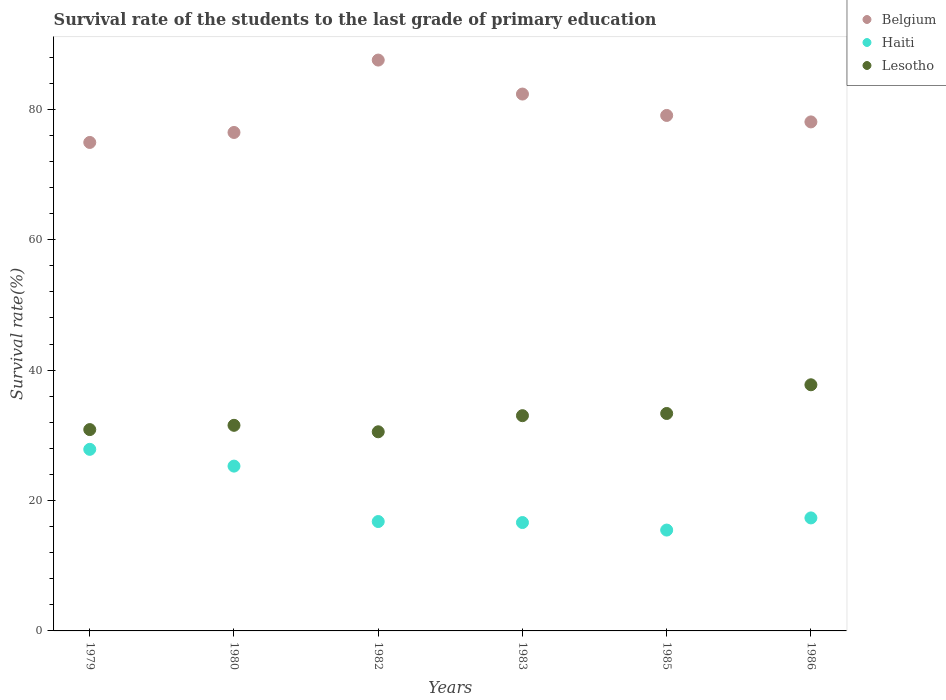Is the number of dotlines equal to the number of legend labels?
Ensure brevity in your answer.  Yes. What is the survival rate of the students in Lesotho in 1983?
Your answer should be very brief. 33.01. Across all years, what is the maximum survival rate of the students in Lesotho?
Make the answer very short. 37.75. Across all years, what is the minimum survival rate of the students in Haiti?
Your response must be concise. 15.47. In which year was the survival rate of the students in Haiti maximum?
Provide a short and direct response. 1979. What is the total survival rate of the students in Haiti in the graph?
Your answer should be compact. 119.33. What is the difference between the survival rate of the students in Lesotho in 1983 and that in 1985?
Provide a short and direct response. -0.34. What is the difference between the survival rate of the students in Haiti in 1985 and the survival rate of the students in Lesotho in 1980?
Provide a succinct answer. -16.07. What is the average survival rate of the students in Haiti per year?
Give a very brief answer. 19.89. In the year 1982, what is the difference between the survival rate of the students in Haiti and survival rate of the students in Lesotho?
Ensure brevity in your answer.  -13.77. In how many years, is the survival rate of the students in Haiti greater than 44 %?
Provide a succinct answer. 0. What is the ratio of the survival rate of the students in Haiti in 1979 to that in 1980?
Give a very brief answer. 1.1. Is the difference between the survival rate of the students in Haiti in 1980 and 1983 greater than the difference between the survival rate of the students in Lesotho in 1980 and 1983?
Ensure brevity in your answer.  Yes. What is the difference between the highest and the second highest survival rate of the students in Lesotho?
Your answer should be very brief. 4.4. What is the difference between the highest and the lowest survival rate of the students in Belgium?
Provide a short and direct response. 12.63. In how many years, is the survival rate of the students in Lesotho greater than the average survival rate of the students in Lesotho taken over all years?
Make the answer very short. 3. How many dotlines are there?
Make the answer very short. 3. How many years are there in the graph?
Offer a very short reply. 6. What is the difference between two consecutive major ticks on the Y-axis?
Your answer should be very brief. 20. Are the values on the major ticks of Y-axis written in scientific E-notation?
Give a very brief answer. No. Does the graph contain any zero values?
Give a very brief answer. No. Where does the legend appear in the graph?
Your answer should be very brief. Top right. How are the legend labels stacked?
Make the answer very short. Vertical. What is the title of the graph?
Keep it short and to the point. Survival rate of the students to the last grade of primary education. What is the label or title of the X-axis?
Offer a terse response. Years. What is the label or title of the Y-axis?
Your answer should be very brief. Survival rate(%). What is the Survival rate(%) of Belgium in 1979?
Your answer should be compact. 74.92. What is the Survival rate(%) of Haiti in 1979?
Provide a short and direct response. 27.85. What is the Survival rate(%) of Lesotho in 1979?
Your response must be concise. 30.88. What is the Survival rate(%) in Belgium in 1980?
Give a very brief answer. 76.45. What is the Survival rate(%) in Haiti in 1980?
Provide a short and direct response. 25.28. What is the Survival rate(%) of Lesotho in 1980?
Offer a terse response. 31.53. What is the Survival rate(%) of Belgium in 1982?
Offer a terse response. 87.55. What is the Survival rate(%) in Haiti in 1982?
Your response must be concise. 16.78. What is the Survival rate(%) in Lesotho in 1982?
Provide a succinct answer. 30.54. What is the Survival rate(%) in Belgium in 1983?
Offer a very short reply. 82.34. What is the Survival rate(%) of Haiti in 1983?
Keep it short and to the point. 16.62. What is the Survival rate(%) in Lesotho in 1983?
Give a very brief answer. 33.01. What is the Survival rate(%) of Belgium in 1985?
Your response must be concise. 79.06. What is the Survival rate(%) in Haiti in 1985?
Your answer should be compact. 15.47. What is the Survival rate(%) of Lesotho in 1985?
Offer a very short reply. 33.35. What is the Survival rate(%) of Belgium in 1986?
Offer a very short reply. 78.07. What is the Survival rate(%) of Haiti in 1986?
Provide a short and direct response. 17.33. What is the Survival rate(%) of Lesotho in 1986?
Your response must be concise. 37.75. Across all years, what is the maximum Survival rate(%) in Belgium?
Your answer should be compact. 87.55. Across all years, what is the maximum Survival rate(%) in Haiti?
Your answer should be very brief. 27.85. Across all years, what is the maximum Survival rate(%) of Lesotho?
Provide a short and direct response. 37.75. Across all years, what is the minimum Survival rate(%) of Belgium?
Give a very brief answer. 74.92. Across all years, what is the minimum Survival rate(%) of Haiti?
Give a very brief answer. 15.47. Across all years, what is the minimum Survival rate(%) of Lesotho?
Your answer should be very brief. 30.54. What is the total Survival rate(%) in Belgium in the graph?
Your response must be concise. 478.4. What is the total Survival rate(%) of Haiti in the graph?
Give a very brief answer. 119.33. What is the total Survival rate(%) in Lesotho in the graph?
Make the answer very short. 197.07. What is the difference between the Survival rate(%) in Belgium in 1979 and that in 1980?
Your response must be concise. -1.53. What is the difference between the Survival rate(%) in Haiti in 1979 and that in 1980?
Offer a terse response. 2.57. What is the difference between the Survival rate(%) of Lesotho in 1979 and that in 1980?
Offer a very short reply. -0.65. What is the difference between the Survival rate(%) in Belgium in 1979 and that in 1982?
Provide a short and direct response. -12.63. What is the difference between the Survival rate(%) in Haiti in 1979 and that in 1982?
Your answer should be compact. 11.07. What is the difference between the Survival rate(%) of Lesotho in 1979 and that in 1982?
Provide a short and direct response. 0.34. What is the difference between the Survival rate(%) of Belgium in 1979 and that in 1983?
Your answer should be very brief. -7.42. What is the difference between the Survival rate(%) of Haiti in 1979 and that in 1983?
Provide a short and direct response. 11.23. What is the difference between the Survival rate(%) of Lesotho in 1979 and that in 1983?
Your response must be concise. -2.13. What is the difference between the Survival rate(%) of Belgium in 1979 and that in 1985?
Ensure brevity in your answer.  -4.14. What is the difference between the Survival rate(%) in Haiti in 1979 and that in 1985?
Give a very brief answer. 12.38. What is the difference between the Survival rate(%) in Lesotho in 1979 and that in 1985?
Your answer should be compact. -2.47. What is the difference between the Survival rate(%) in Belgium in 1979 and that in 1986?
Your answer should be very brief. -3.15. What is the difference between the Survival rate(%) in Haiti in 1979 and that in 1986?
Give a very brief answer. 10.52. What is the difference between the Survival rate(%) in Lesotho in 1979 and that in 1986?
Provide a succinct answer. -6.87. What is the difference between the Survival rate(%) of Belgium in 1980 and that in 1982?
Your answer should be compact. -11.1. What is the difference between the Survival rate(%) in Haiti in 1980 and that in 1982?
Make the answer very short. 8.5. What is the difference between the Survival rate(%) of Belgium in 1980 and that in 1983?
Ensure brevity in your answer.  -5.89. What is the difference between the Survival rate(%) in Haiti in 1980 and that in 1983?
Provide a short and direct response. 8.65. What is the difference between the Survival rate(%) of Lesotho in 1980 and that in 1983?
Your answer should be compact. -1.48. What is the difference between the Survival rate(%) in Belgium in 1980 and that in 1985?
Provide a short and direct response. -2.61. What is the difference between the Survival rate(%) of Haiti in 1980 and that in 1985?
Your answer should be very brief. 9.81. What is the difference between the Survival rate(%) of Lesotho in 1980 and that in 1985?
Give a very brief answer. -1.82. What is the difference between the Survival rate(%) in Belgium in 1980 and that in 1986?
Keep it short and to the point. -1.62. What is the difference between the Survival rate(%) of Haiti in 1980 and that in 1986?
Your answer should be very brief. 7.95. What is the difference between the Survival rate(%) in Lesotho in 1980 and that in 1986?
Your response must be concise. -6.22. What is the difference between the Survival rate(%) in Belgium in 1982 and that in 1983?
Your answer should be compact. 5.21. What is the difference between the Survival rate(%) of Haiti in 1982 and that in 1983?
Give a very brief answer. 0.15. What is the difference between the Survival rate(%) in Lesotho in 1982 and that in 1983?
Offer a terse response. -2.47. What is the difference between the Survival rate(%) of Belgium in 1982 and that in 1985?
Your response must be concise. 8.49. What is the difference between the Survival rate(%) of Haiti in 1982 and that in 1985?
Ensure brevity in your answer.  1.31. What is the difference between the Survival rate(%) in Lesotho in 1982 and that in 1985?
Your answer should be compact. -2.81. What is the difference between the Survival rate(%) of Belgium in 1982 and that in 1986?
Give a very brief answer. 9.48. What is the difference between the Survival rate(%) of Haiti in 1982 and that in 1986?
Your answer should be very brief. -0.56. What is the difference between the Survival rate(%) of Lesotho in 1982 and that in 1986?
Offer a terse response. -7.21. What is the difference between the Survival rate(%) of Belgium in 1983 and that in 1985?
Offer a terse response. 3.28. What is the difference between the Survival rate(%) in Haiti in 1983 and that in 1985?
Provide a succinct answer. 1.16. What is the difference between the Survival rate(%) of Lesotho in 1983 and that in 1985?
Your answer should be compact. -0.34. What is the difference between the Survival rate(%) in Belgium in 1983 and that in 1986?
Keep it short and to the point. 4.27. What is the difference between the Survival rate(%) of Haiti in 1983 and that in 1986?
Your answer should be compact. -0.71. What is the difference between the Survival rate(%) of Lesotho in 1983 and that in 1986?
Your response must be concise. -4.74. What is the difference between the Survival rate(%) in Belgium in 1985 and that in 1986?
Give a very brief answer. 0.99. What is the difference between the Survival rate(%) in Haiti in 1985 and that in 1986?
Offer a very short reply. -1.86. What is the difference between the Survival rate(%) of Lesotho in 1985 and that in 1986?
Give a very brief answer. -4.4. What is the difference between the Survival rate(%) in Belgium in 1979 and the Survival rate(%) in Haiti in 1980?
Your answer should be very brief. 49.64. What is the difference between the Survival rate(%) of Belgium in 1979 and the Survival rate(%) of Lesotho in 1980?
Your answer should be compact. 43.39. What is the difference between the Survival rate(%) of Haiti in 1979 and the Survival rate(%) of Lesotho in 1980?
Give a very brief answer. -3.68. What is the difference between the Survival rate(%) of Belgium in 1979 and the Survival rate(%) of Haiti in 1982?
Your answer should be very brief. 58.14. What is the difference between the Survival rate(%) in Belgium in 1979 and the Survival rate(%) in Lesotho in 1982?
Your response must be concise. 44.38. What is the difference between the Survival rate(%) in Haiti in 1979 and the Survival rate(%) in Lesotho in 1982?
Make the answer very short. -2.69. What is the difference between the Survival rate(%) of Belgium in 1979 and the Survival rate(%) of Haiti in 1983?
Your response must be concise. 58.3. What is the difference between the Survival rate(%) in Belgium in 1979 and the Survival rate(%) in Lesotho in 1983?
Offer a terse response. 41.91. What is the difference between the Survival rate(%) of Haiti in 1979 and the Survival rate(%) of Lesotho in 1983?
Make the answer very short. -5.16. What is the difference between the Survival rate(%) in Belgium in 1979 and the Survival rate(%) in Haiti in 1985?
Offer a terse response. 59.45. What is the difference between the Survival rate(%) in Belgium in 1979 and the Survival rate(%) in Lesotho in 1985?
Your response must be concise. 41.57. What is the difference between the Survival rate(%) in Haiti in 1979 and the Survival rate(%) in Lesotho in 1985?
Keep it short and to the point. -5.5. What is the difference between the Survival rate(%) of Belgium in 1979 and the Survival rate(%) of Haiti in 1986?
Your response must be concise. 57.59. What is the difference between the Survival rate(%) in Belgium in 1979 and the Survival rate(%) in Lesotho in 1986?
Give a very brief answer. 37.17. What is the difference between the Survival rate(%) in Haiti in 1979 and the Survival rate(%) in Lesotho in 1986?
Give a very brief answer. -9.9. What is the difference between the Survival rate(%) in Belgium in 1980 and the Survival rate(%) in Haiti in 1982?
Make the answer very short. 59.68. What is the difference between the Survival rate(%) in Belgium in 1980 and the Survival rate(%) in Lesotho in 1982?
Offer a terse response. 45.91. What is the difference between the Survival rate(%) in Haiti in 1980 and the Survival rate(%) in Lesotho in 1982?
Keep it short and to the point. -5.26. What is the difference between the Survival rate(%) of Belgium in 1980 and the Survival rate(%) of Haiti in 1983?
Offer a very short reply. 59.83. What is the difference between the Survival rate(%) in Belgium in 1980 and the Survival rate(%) in Lesotho in 1983?
Provide a succinct answer. 43.44. What is the difference between the Survival rate(%) of Haiti in 1980 and the Survival rate(%) of Lesotho in 1983?
Provide a succinct answer. -7.74. What is the difference between the Survival rate(%) of Belgium in 1980 and the Survival rate(%) of Haiti in 1985?
Your answer should be very brief. 60.98. What is the difference between the Survival rate(%) in Belgium in 1980 and the Survival rate(%) in Lesotho in 1985?
Ensure brevity in your answer.  43.1. What is the difference between the Survival rate(%) of Haiti in 1980 and the Survival rate(%) of Lesotho in 1985?
Your answer should be very brief. -8.07. What is the difference between the Survival rate(%) of Belgium in 1980 and the Survival rate(%) of Haiti in 1986?
Your answer should be very brief. 59.12. What is the difference between the Survival rate(%) in Belgium in 1980 and the Survival rate(%) in Lesotho in 1986?
Your answer should be compact. 38.7. What is the difference between the Survival rate(%) of Haiti in 1980 and the Survival rate(%) of Lesotho in 1986?
Your response must be concise. -12.47. What is the difference between the Survival rate(%) in Belgium in 1982 and the Survival rate(%) in Haiti in 1983?
Offer a very short reply. 70.93. What is the difference between the Survival rate(%) of Belgium in 1982 and the Survival rate(%) of Lesotho in 1983?
Ensure brevity in your answer.  54.54. What is the difference between the Survival rate(%) in Haiti in 1982 and the Survival rate(%) in Lesotho in 1983?
Your response must be concise. -16.24. What is the difference between the Survival rate(%) in Belgium in 1982 and the Survival rate(%) in Haiti in 1985?
Your response must be concise. 72.09. What is the difference between the Survival rate(%) in Belgium in 1982 and the Survival rate(%) in Lesotho in 1985?
Ensure brevity in your answer.  54.2. What is the difference between the Survival rate(%) in Haiti in 1982 and the Survival rate(%) in Lesotho in 1985?
Provide a succinct answer. -16.57. What is the difference between the Survival rate(%) in Belgium in 1982 and the Survival rate(%) in Haiti in 1986?
Offer a very short reply. 70.22. What is the difference between the Survival rate(%) in Belgium in 1982 and the Survival rate(%) in Lesotho in 1986?
Ensure brevity in your answer.  49.8. What is the difference between the Survival rate(%) in Haiti in 1982 and the Survival rate(%) in Lesotho in 1986?
Your answer should be compact. -20.98. What is the difference between the Survival rate(%) in Belgium in 1983 and the Survival rate(%) in Haiti in 1985?
Give a very brief answer. 66.87. What is the difference between the Survival rate(%) in Belgium in 1983 and the Survival rate(%) in Lesotho in 1985?
Make the answer very short. 48.99. What is the difference between the Survival rate(%) in Haiti in 1983 and the Survival rate(%) in Lesotho in 1985?
Provide a succinct answer. -16.73. What is the difference between the Survival rate(%) of Belgium in 1983 and the Survival rate(%) of Haiti in 1986?
Make the answer very short. 65.01. What is the difference between the Survival rate(%) in Belgium in 1983 and the Survival rate(%) in Lesotho in 1986?
Provide a succinct answer. 44.59. What is the difference between the Survival rate(%) of Haiti in 1983 and the Survival rate(%) of Lesotho in 1986?
Your answer should be very brief. -21.13. What is the difference between the Survival rate(%) of Belgium in 1985 and the Survival rate(%) of Haiti in 1986?
Your answer should be compact. 61.73. What is the difference between the Survival rate(%) in Belgium in 1985 and the Survival rate(%) in Lesotho in 1986?
Make the answer very short. 41.31. What is the difference between the Survival rate(%) in Haiti in 1985 and the Survival rate(%) in Lesotho in 1986?
Your answer should be very brief. -22.28. What is the average Survival rate(%) in Belgium per year?
Ensure brevity in your answer.  79.73. What is the average Survival rate(%) in Haiti per year?
Make the answer very short. 19.89. What is the average Survival rate(%) of Lesotho per year?
Offer a terse response. 32.85. In the year 1979, what is the difference between the Survival rate(%) of Belgium and Survival rate(%) of Haiti?
Give a very brief answer. 47.07. In the year 1979, what is the difference between the Survival rate(%) of Belgium and Survival rate(%) of Lesotho?
Make the answer very short. 44.04. In the year 1979, what is the difference between the Survival rate(%) in Haiti and Survival rate(%) in Lesotho?
Keep it short and to the point. -3.03. In the year 1980, what is the difference between the Survival rate(%) in Belgium and Survival rate(%) in Haiti?
Ensure brevity in your answer.  51.17. In the year 1980, what is the difference between the Survival rate(%) in Belgium and Survival rate(%) in Lesotho?
Your response must be concise. 44.92. In the year 1980, what is the difference between the Survival rate(%) in Haiti and Survival rate(%) in Lesotho?
Your response must be concise. -6.26. In the year 1982, what is the difference between the Survival rate(%) of Belgium and Survival rate(%) of Haiti?
Provide a succinct answer. 70.78. In the year 1982, what is the difference between the Survival rate(%) of Belgium and Survival rate(%) of Lesotho?
Keep it short and to the point. 57.01. In the year 1982, what is the difference between the Survival rate(%) in Haiti and Survival rate(%) in Lesotho?
Keep it short and to the point. -13.77. In the year 1983, what is the difference between the Survival rate(%) of Belgium and Survival rate(%) of Haiti?
Provide a succinct answer. 65.72. In the year 1983, what is the difference between the Survival rate(%) of Belgium and Survival rate(%) of Lesotho?
Provide a succinct answer. 49.33. In the year 1983, what is the difference between the Survival rate(%) of Haiti and Survival rate(%) of Lesotho?
Your response must be concise. -16.39. In the year 1985, what is the difference between the Survival rate(%) of Belgium and Survival rate(%) of Haiti?
Provide a short and direct response. 63.59. In the year 1985, what is the difference between the Survival rate(%) of Belgium and Survival rate(%) of Lesotho?
Your answer should be very brief. 45.71. In the year 1985, what is the difference between the Survival rate(%) in Haiti and Survival rate(%) in Lesotho?
Your answer should be compact. -17.88. In the year 1986, what is the difference between the Survival rate(%) in Belgium and Survival rate(%) in Haiti?
Offer a very short reply. 60.74. In the year 1986, what is the difference between the Survival rate(%) in Belgium and Survival rate(%) in Lesotho?
Give a very brief answer. 40.32. In the year 1986, what is the difference between the Survival rate(%) of Haiti and Survival rate(%) of Lesotho?
Keep it short and to the point. -20.42. What is the ratio of the Survival rate(%) of Haiti in 1979 to that in 1980?
Make the answer very short. 1.1. What is the ratio of the Survival rate(%) in Lesotho in 1979 to that in 1980?
Your response must be concise. 0.98. What is the ratio of the Survival rate(%) of Belgium in 1979 to that in 1982?
Provide a short and direct response. 0.86. What is the ratio of the Survival rate(%) in Haiti in 1979 to that in 1982?
Your answer should be compact. 1.66. What is the ratio of the Survival rate(%) of Lesotho in 1979 to that in 1982?
Give a very brief answer. 1.01. What is the ratio of the Survival rate(%) in Belgium in 1979 to that in 1983?
Make the answer very short. 0.91. What is the ratio of the Survival rate(%) of Haiti in 1979 to that in 1983?
Your answer should be compact. 1.68. What is the ratio of the Survival rate(%) of Lesotho in 1979 to that in 1983?
Offer a very short reply. 0.94. What is the ratio of the Survival rate(%) of Belgium in 1979 to that in 1985?
Your answer should be very brief. 0.95. What is the ratio of the Survival rate(%) of Haiti in 1979 to that in 1985?
Give a very brief answer. 1.8. What is the ratio of the Survival rate(%) of Lesotho in 1979 to that in 1985?
Your answer should be compact. 0.93. What is the ratio of the Survival rate(%) in Belgium in 1979 to that in 1986?
Ensure brevity in your answer.  0.96. What is the ratio of the Survival rate(%) of Haiti in 1979 to that in 1986?
Your answer should be very brief. 1.61. What is the ratio of the Survival rate(%) in Lesotho in 1979 to that in 1986?
Keep it short and to the point. 0.82. What is the ratio of the Survival rate(%) of Belgium in 1980 to that in 1982?
Your answer should be very brief. 0.87. What is the ratio of the Survival rate(%) of Haiti in 1980 to that in 1982?
Your answer should be very brief. 1.51. What is the ratio of the Survival rate(%) in Lesotho in 1980 to that in 1982?
Provide a short and direct response. 1.03. What is the ratio of the Survival rate(%) in Belgium in 1980 to that in 1983?
Your response must be concise. 0.93. What is the ratio of the Survival rate(%) of Haiti in 1980 to that in 1983?
Provide a succinct answer. 1.52. What is the ratio of the Survival rate(%) in Lesotho in 1980 to that in 1983?
Your response must be concise. 0.96. What is the ratio of the Survival rate(%) of Haiti in 1980 to that in 1985?
Give a very brief answer. 1.63. What is the ratio of the Survival rate(%) of Lesotho in 1980 to that in 1985?
Keep it short and to the point. 0.95. What is the ratio of the Survival rate(%) in Belgium in 1980 to that in 1986?
Your answer should be very brief. 0.98. What is the ratio of the Survival rate(%) of Haiti in 1980 to that in 1986?
Offer a very short reply. 1.46. What is the ratio of the Survival rate(%) in Lesotho in 1980 to that in 1986?
Offer a terse response. 0.84. What is the ratio of the Survival rate(%) of Belgium in 1982 to that in 1983?
Give a very brief answer. 1.06. What is the ratio of the Survival rate(%) in Haiti in 1982 to that in 1983?
Your response must be concise. 1.01. What is the ratio of the Survival rate(%) in Lesotho in 1982 to that in 1983?
Your response must be concise. 0.93. What is the ratio of the Survival rate(%) in Belgium in 1982 to that in 1985?
Offer a very short reply. 1.11. What is the ratio of the Survival rate(%) of Haiti in 1982 to that in 1985?
Keep it short and to the point. 1.08. What is the ratio of the Survival rate(%) of Lesotho in 1982 to that in 1985?
Make the answer very short. 0.92. What is the ratio of the Survival rate(%) of Belgium in 1982 to that in 1986?
Ensure brevity in your answer.  1.12. What is the ratio of the Survival rate(%) of Haiti in 1982 to that in 1986?
Your answer should be very brief. 0.97. What is the ratio of the Survival rate(%) of Lesotho in 1982 to that in 1986?
Ensure brevity in your answer.  0.81. What is the ratio of the Survival rate(%) in Belgium in 1983 to that in 1985?
Your answer should be very brief. 1.04. What is the ratio of the Survival rate(%) of Haiti in 1983 to that in 1985?
Provide a succinct answer. 1.07. What is the ratio of the Survival rate(%) in Lesotho in 1983 to that in 1985?
Give a very brief answer. 0.99. What is the ratio of the Survival rate(%) in Belgium in 1983 to that in 1986?
Your response must be concise. 1.05. What is the ratio of the Survival rate(%) of Haiti in 1983 to that in 1986?
Keep it short and to the point. 0.96. What is the ratio of the Survival rate(%) of Lesotho in 1983 to that in 1986?
Provide a short and direct response. 0.87. What is the ratio of the Survival rate(%) of Belgium in 1985 to that in 1986?
Make the answer very short. 1.01. What is the ratio of the Survival rate(%) of Haiti in 1985 to that in 1986?
Your response must be concise. 0.89. What is the ratio of the Survival rate(%) of Lesotho in 1985 to that in 1986?
Give a very brief answer. 0.88. What is the difference between the highest and the second highest Survival rate(%) of Belgium?
Provide a succinct answer. 5.21. What is the difference between the highest and the second highest Survival rate(%) of Haiti?
Make the answer very short. 2.57. What is the difference between the highest and the second highest Survival rate(%) in Lesotho?
Provide a succinct answer. 4.4. What is the difference between the highest and the lowest Survival rate(%) in Belgium?
Provide a short and direct response. 12.63. What is the difference between the highest and the lowest Survival rate(%) in Haiti?
Provide a short and direct response. 12.38. What is the difference between the highest and the lowest Survival rate(%) of Lesotho?
Make the answer very short. 7.21. 